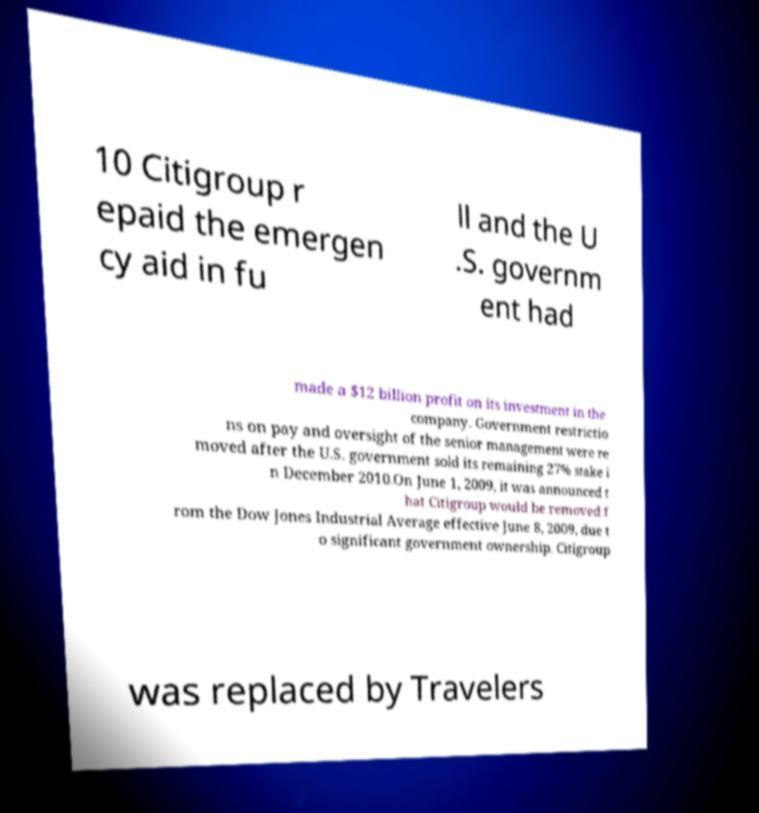Could you assist in decoding the text presented in this image and type it out clearly? 10 Citigroup r epaid the emergen cy aid in fu ll and the U .S. governm ent had made a $12 billion profit on its investment in the company. Government restrictio ns on pay and oversight of the senior management were re moved after the U.S. government sold its remaining 27% stake i n December 2010.On June 1, 2009, it was announced t hat Citigroup would be removed f rom the Dow Jones Industrial Average effective June 8, 2009, due t o significant government ownership. Citigroup was replaced by Travelers 